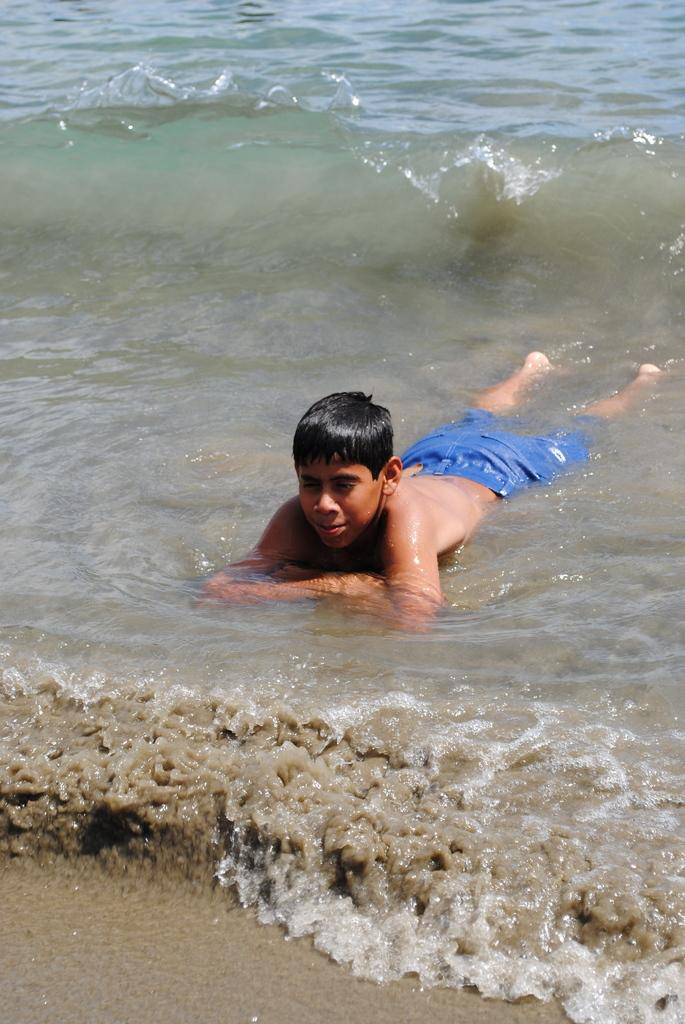Who is present in the image? There is a boy in the image. Where is the boy located? The boy is in the water. What is the rate at which the tomatoes are growing in the garden in the image? There is no garden or tomatoes present in the image; it only features a boy in the water. 